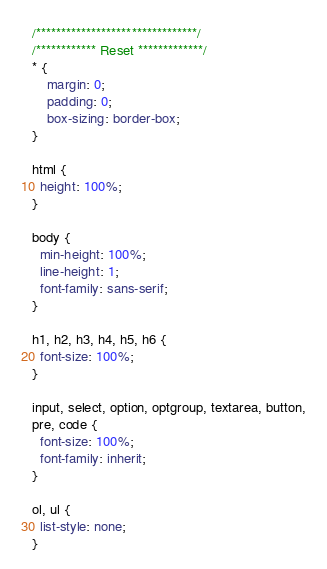Convert code to text. <code><loc_0><loc_0><loc_500><loc_500><_CSS_>/********************************/
/************ Reset *************/
* {
    margin: 0;
    padding: 0;
    box-sizing: border-box;
}

html {
  height: 100%;
}

body {
  min-height: 100%;
  line-height: 1;
  font-family: sans-serif;
}

h1, h2, h3, h4, h5, h6 {
  font-size: 100%;
}

input, select, option, optgroup, textarea, button,
pre, code {
  font-size: 100%;
  font-family: inherit;
}

ol, ul {
  list-style: none;
}</code> 